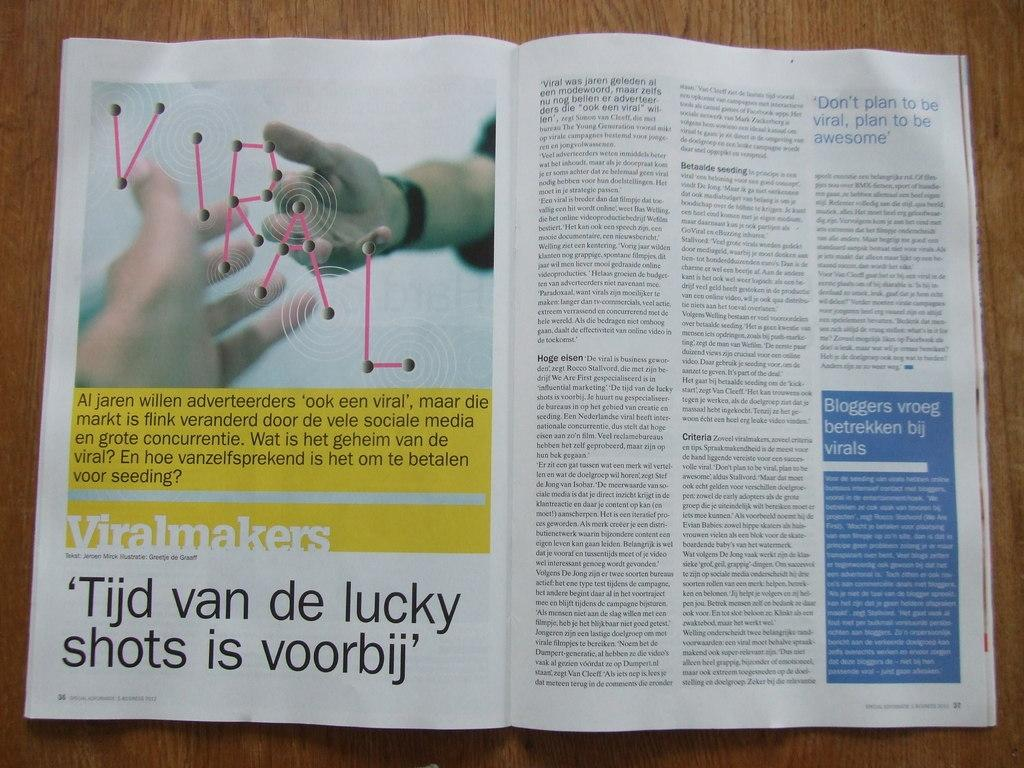<image>
Render a clear and concise summary of the photo. A magazine is open to a page with the word Viralmakers on it . 